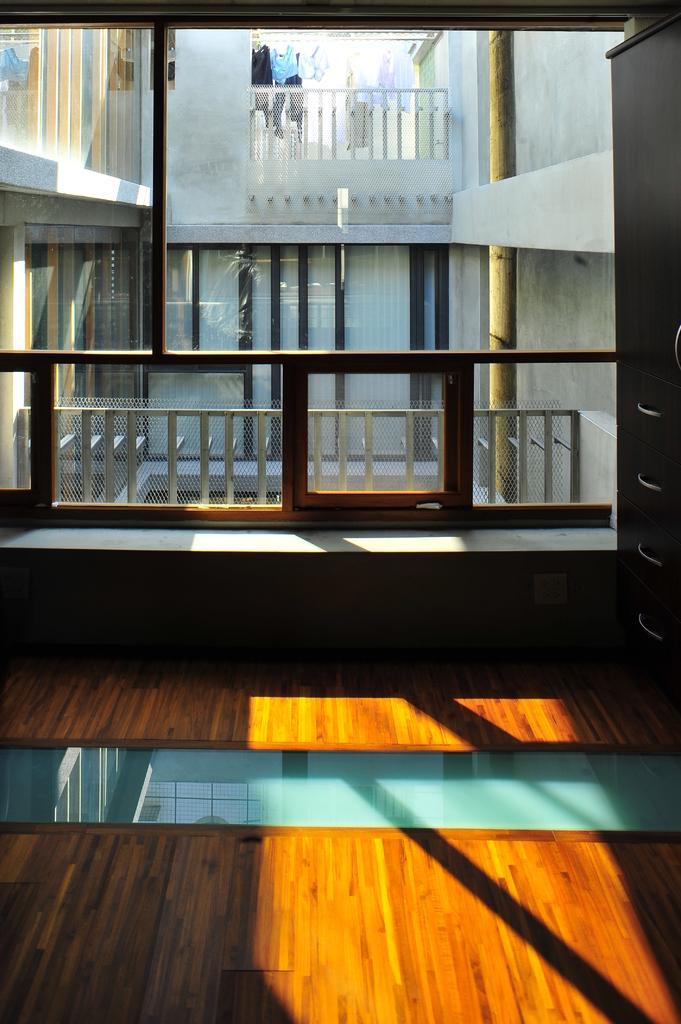Describe this image in one or two sentences. In this image we can see glass windows, fencing, pole, door and building. 